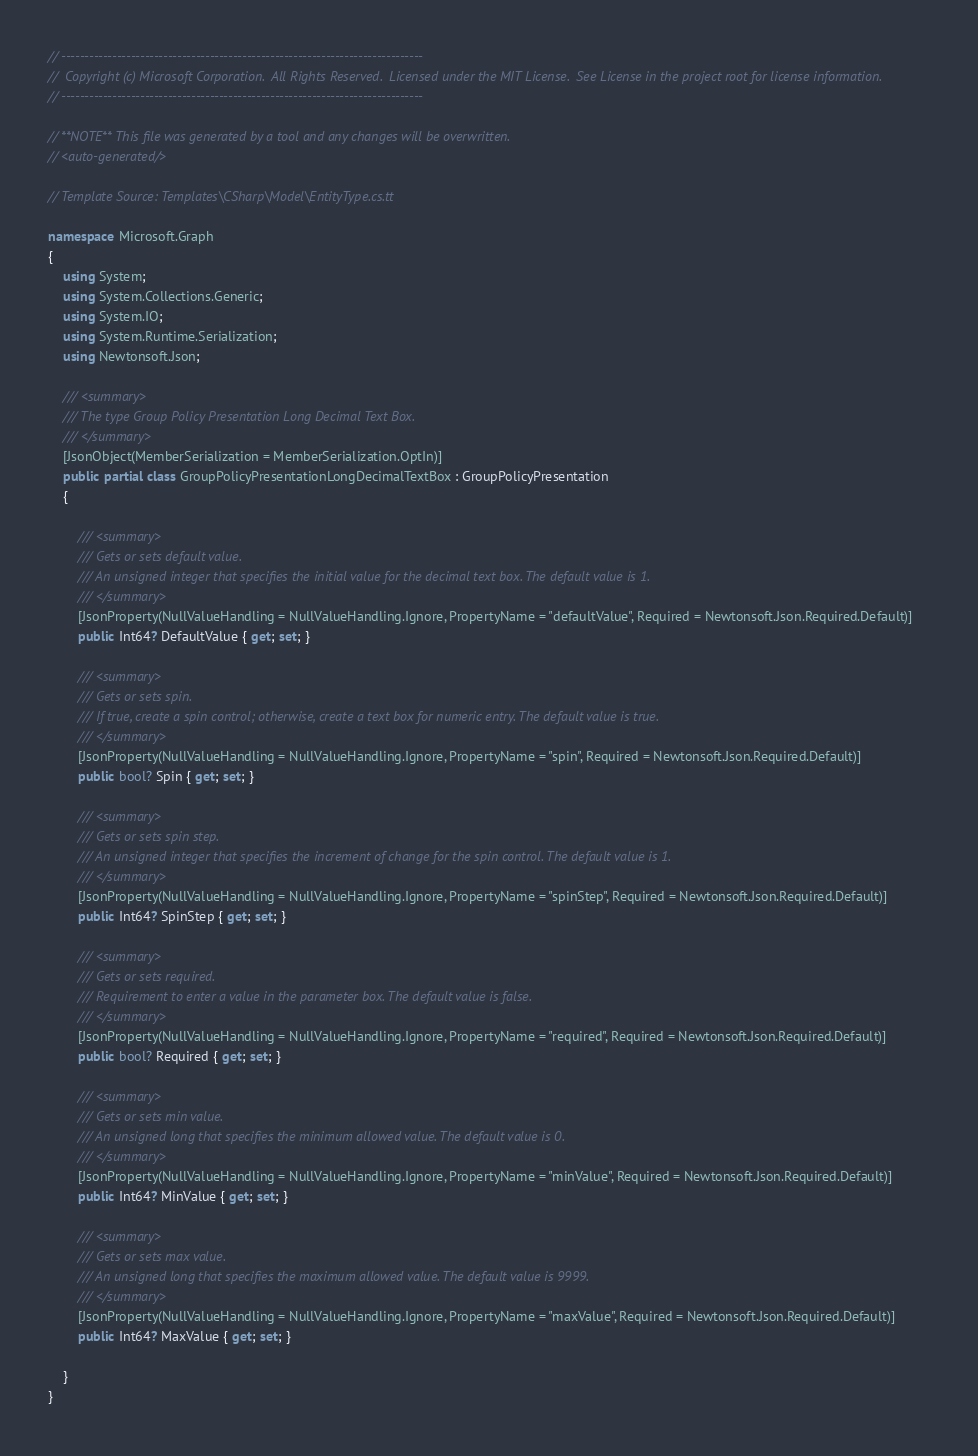Convert code to text. <code><loc_0><loc_0><loc_500><loc_500><_C#_>// ------------------------------------------------------------------------------
//  Copyright (c) Microsoft Corporation.  All Rights Reserved.  Licensed under the MIT License.  See License in the project root for license information.
// ------------------------------------------------------------------------------

// **NOTE** This file was generated by a tool and any changes will be overwritten.
// <auto-generated/>

// Template Source: Templates\CSharp\Model\EntityType.cs.tt

namespace Microsoft.Graph
{
    using System;
    using System.Collections.Generic;
    using System.IO;
    using System.Runtime.Serialization;
    using Newtonsoft.Json;

    /// <summary>
    /// The type Group Policy Presentation Long Decimal Text Box.
    /// </summary>
    [JsonObject(MemberSerialization = MemberSerialization.OptIn)]
    public partial class GroupPolicyPresentationLongDecimalTextBox : GroupPolicyPresentation
    {
    
        /// <summary>
        /// Gets or sets default value.
        /// An unsigned integer that specifies the initial value for the decimal text box. The default value is 1.
        /// </summary>
        [JsonProperty(NullValueHandling = NullValueHandling.Ignore, PropertyName = "defaultValue", Required = Newtonsoft.Json.Required.Default)]
        public Int64? DefaultValue { get; set; }
    
        /// <summary>
        /// Gets or sets spin.
        /// If true, create a spin control; otherwise, create a text box for numeric entry. The default value is true.
        /// </summary>
        [JsonProperty(NullValueHandling = NullValueHandling.Ignore, PropertyName = "spin", Required = Newtonsoft.Json.Required.Default)]
        public bool? Spin { get; set; }
    
        /// <summary>
        /// Gets or sets spin step.
        /// An unsigned integer that specifies the increment of change for the spin control. The default value is 1.
        /// </summary>
        [JsonProperty(NullValueHandling = NullValueHandling.Ignore, PropertyName = "spinStep", Required = Newtonsoft.Json.Required.Default)]
        public Int64? SpinStep { get; set; }
    
        /// <summary>
        /// Gets or sets required.
        /// Requirement to enter a value in the parameter box. The default value is false.
        /// </summary>
        [JsonProperty(NullValueHandling = NullValueHandling.Ignore, PropertyName = "required", Required = Newtonsoft.Json.Required.Default)]
        public bool? Required { get; set; }
    
        /// <summary>
        /// Gets or sets min value.
        /// An unsigned long that specifies the minimum allowed value. The default value is 0.
        /// </summary>
        [JsonProperty(NullValueHandling = NullValueHandling.Ignore, PropertyName = "minValue", Required = Newtonsoft.Json.Required.Default)]
        public Int64? MinValue { get; set; }
    
        /// <summary>
        /// Gets or sets max value.
        /// An unsigned long that specifies the maximum allowed value. The default value is 9999.
        /// </summary>
        [JsonProperty(NullValueHandling = NullValueHandling.Ignore, PropertyName = "maxValue", Required = Newtonsoft.Json.Required.Default)]
        public Int64? MaxValue { get; set; }
    
    }
}

</code> 